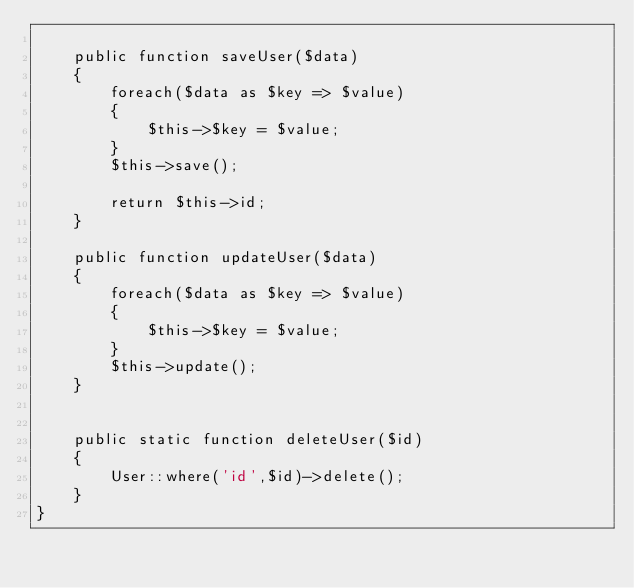Convert code to text. <code><loc_0><loc_0><loc_500><loc_500><_PHP_>
    public function saveUser($data)
    {
        foreach($data as $key => $value)
        {
            $this->$key = $value;
        }
        $this->save();

        return $this->id;
    }

    public function updateUser($data)
    {
        foreach($data as $key => $value)
        {
            $this->$key = $value;
        }
        $this->update();
    }


    public static function deleteUser($id)
    {
        User::where('id',$id)->delete();
    }
}
</code> 